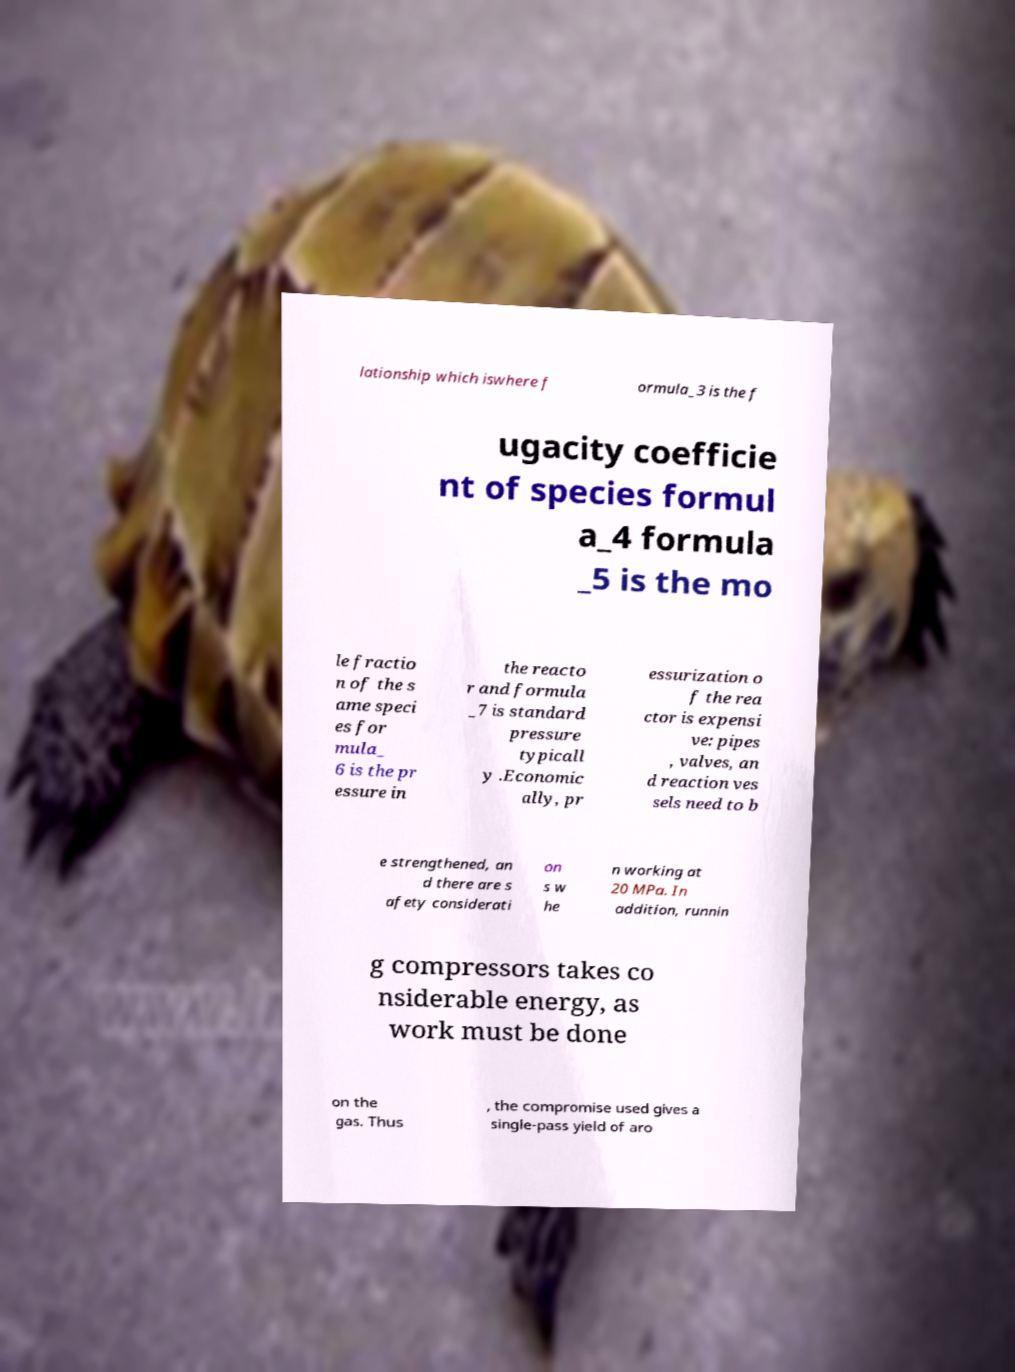For documentation purposes, I need the text within this image transcribed. Could you provide that? lationship which iswhere f ormula_3 is the f ugacity coefficie nt of species formul a_4 formula _5 is the mo le fractio n of the s ame speci es for mula_ 6 is the pr essure in the reacto r and formula _7 is standard pressure typicall y .Economic ally, pr essurization o f the rea ctor is expensi ve: pipes , valves, an d reaction ves sels need to b e strengthened, an d there are s afety considerati on s w he n working at 20 MPa. In addition, runnin g compressors takes co nsiderable energy, as work must be done on the gas. Thus , the compromise used gives a single-pass yield of aro 